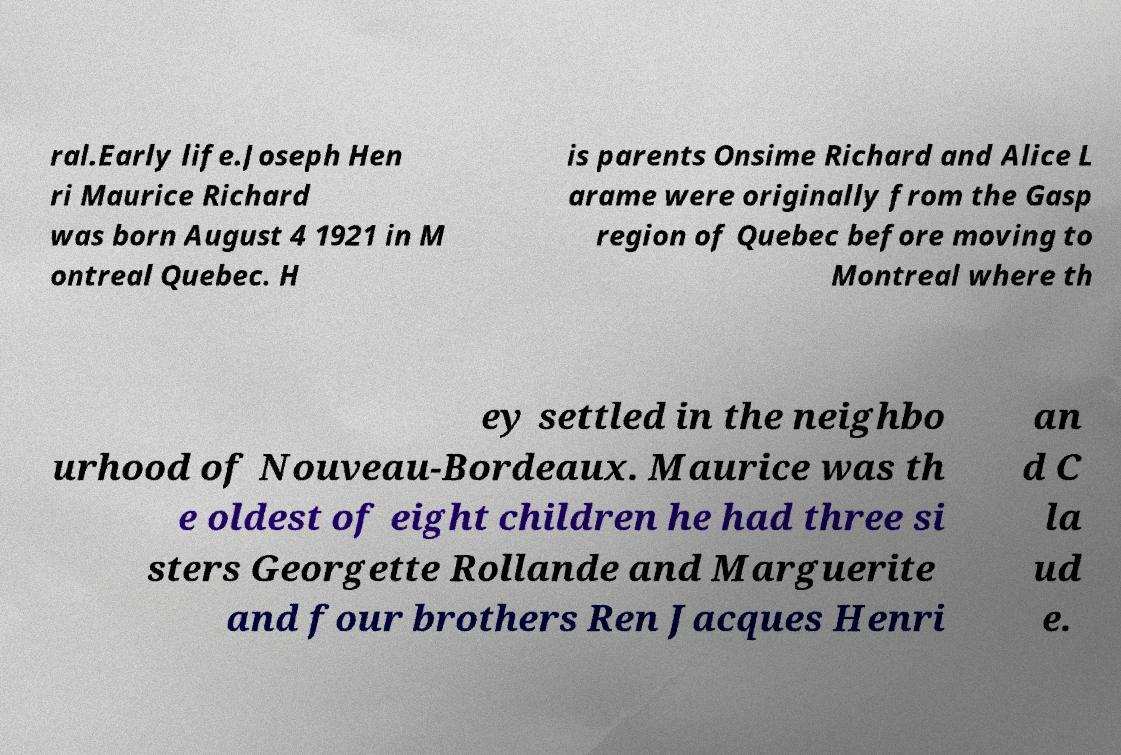Can you read and provide the text displayed in the image?This photo seems to have some interesting text. Can you extract and type it out for me? ral.Early life.Joseph Hen ri Maurice Richard was born August 4 1921 in M ontreal Quebec. H is parents Onsime Richard and Alice L arame were originally from the Gasp region of Quebec before moving to Montreal where th ey settled in the neighbo urhood of Nouveau-Bordeaux. Maurice was th e oldest of eight children he had three si sters Georgette Rollande and Marguerite and four brothers Ren Jacques Henri an d C la ud e. 